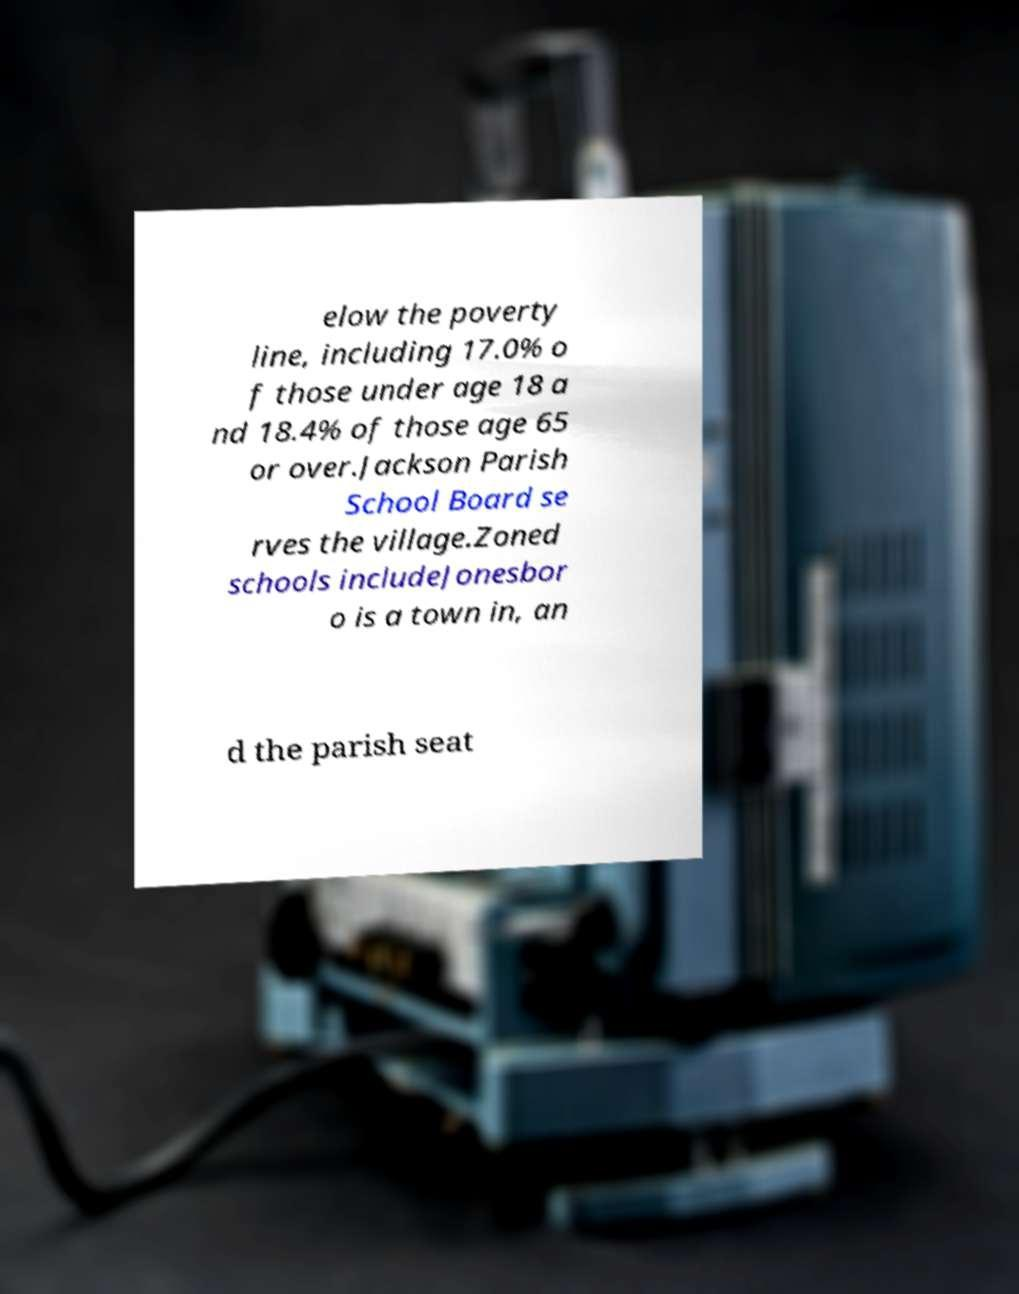Could you extract and type out the text from this image? elow the poverty line, including 17.0% o f those under age 18 a nd 18.4% of those age 65 or over.Jackson Parish School Board se rves the village.Zoned schools includeJonesbor o is a town in, an d the parish seat 